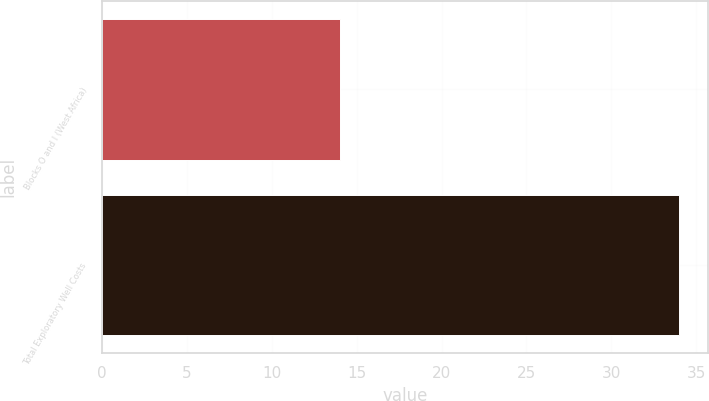Convert chart. <chart><loc_0><loc_0><loc_500><loc_500><bar_chart><fcel>Blocks O and I (West Africa)<fcel>Total Exploratory Well Costs<nl><fcel>14<fcel>34<nl></chart> 